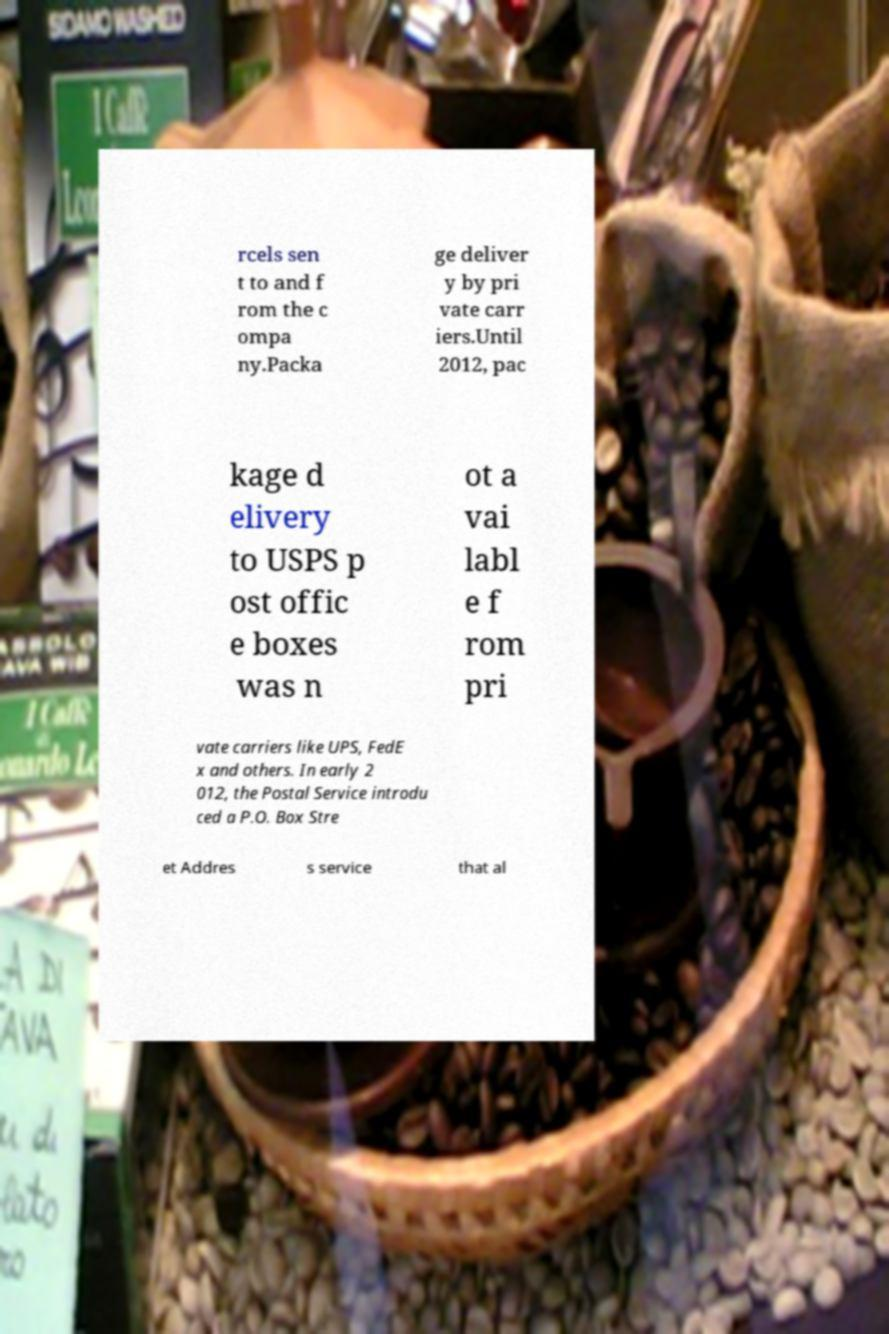For documentation purposes, I need the text within this image transcribed. Could you provide that? rcels sen t to and f rom the c ompa ny.Packa ge deliver y by pri vate carr iers.Until 2012, pac kage d elivery to USPS p ost offic e boxes was n ot a vai labl e f rom pri vate carriers like UPS, FedE x and others. In early 2 012, the Postal Service introdu ced a P.O. Box Stre et Addres s service that al 